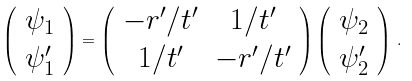Convert formula to latex. <formula><loc_0><loc_0><loc_500><loc_500>\left ( \begin{array} { c } \psi _ { 1 } \\ \psi _ { 1 } ^ { \prime } \end{array} \right ) = \left ( \begin{array} { c c } - r ^ { \prime } / t ^ { \prime } & 1 / t ^ { \prime } \\ 1 / t ^ { \prime } & - r ^ { \prime } / t ^ { \prime } \end{array} \right ) \left ( \begin{array} { c } \psi _ { 2 } \\ \psi _ { 2 } ^ { \prime } \end{array} \right ) \, .</formula> 